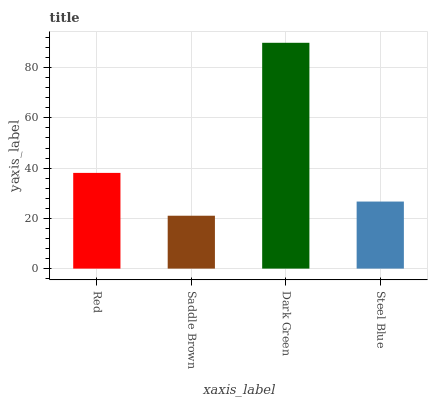Is Saddle Brown the minimum?
Answer yes or no. Yes. Is Dark Green the maximum?
Answer yes or no. Yes. Is Dark Green the minimum?
Answer yes or no. No. Is Saddle Brown the maximum?
Answer yes or no. No. Is Dark Green greater than Saddle Brown?
Answer yes or no. Yes. Is Saddle Brown less than Dark Green?
Answer yes or no. Yes. Is Saddle Brown greater than Dark Green?
Answer yes or no. No. Is Dark Green less than Saddle Brown?
Answer yes or no. No. Is Red the high median?
Answer yes or no. Yes. Is Steel Blue the low median?
Answer yes or no. Yes. Is Dark Green the high median?
Answer yes or no. No. Is Dark Green the low median?
Answer yes or no. No. 